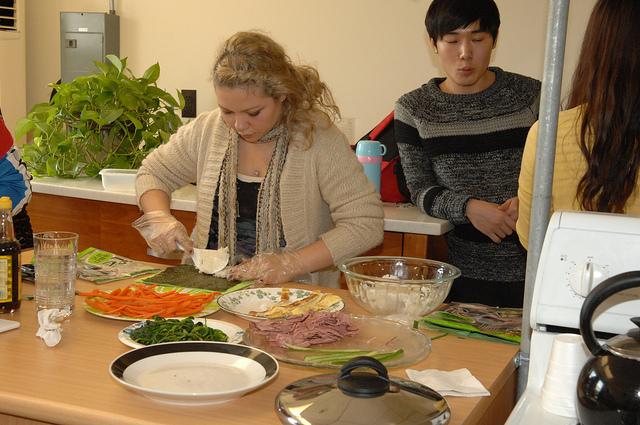How many empty glasses are on the table?
Concise answer only. 1. What is this person preparing?
Quick response, please. Sushi. Where are some white cups?
Be succinct. Stove. What type of design is on the plates?
Be succinct. Floral. Are they happy?
Write a very short answer. Yes. How many women are in this picture?
Write a very short answer. 2. What type of establishment is featured in the picture?
Answer briefly. House. What kind of party is being celebrated?
Concise answer only. Graduation. Is this someone's home?
Keep it brief. Yes. What color are the plates?
Write a very short answer. White. Is the woman looking forward to the meal?
Concise answer only. Yes. How many glass objects?
Answer briefly. 3. 